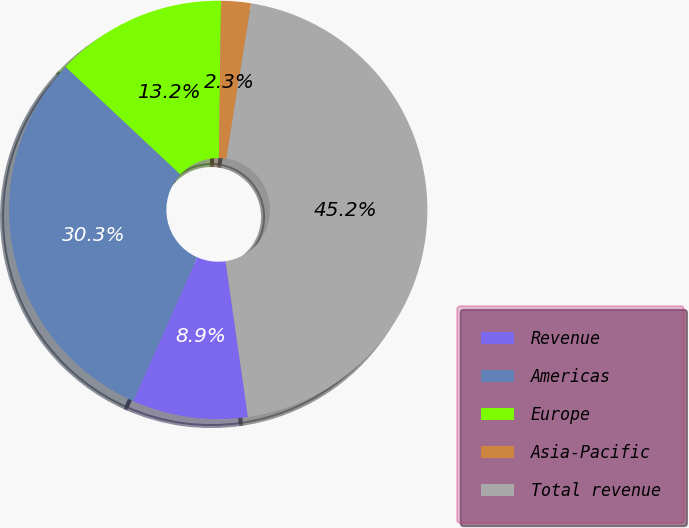Convert chart to OTSL. <chart><loc_0><loc_0><loc_500><loc_500><pie_chart><fcel>Revenue<fcel>Americas<fcel>Europe<fcel>Asia-Pacific<fcel>Total revenue<nl><fcel>8.94%<fcel>30.32%<fcel>13.23%<fcel>2.3%<fcel>45.2%<nl></chart> 